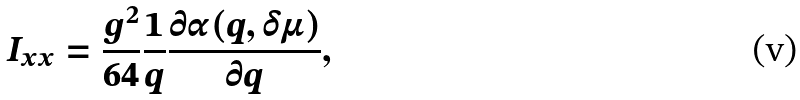<formula> <loc_0><loc_0><loc_500><loc_500>I _ { x x } = \frac { g ^ { 2 } } { 6 4 } \frac { 1 } { q } \frac { \partial \alpha ( q , \delta \mu ) } { \partial q } ,</formula> 